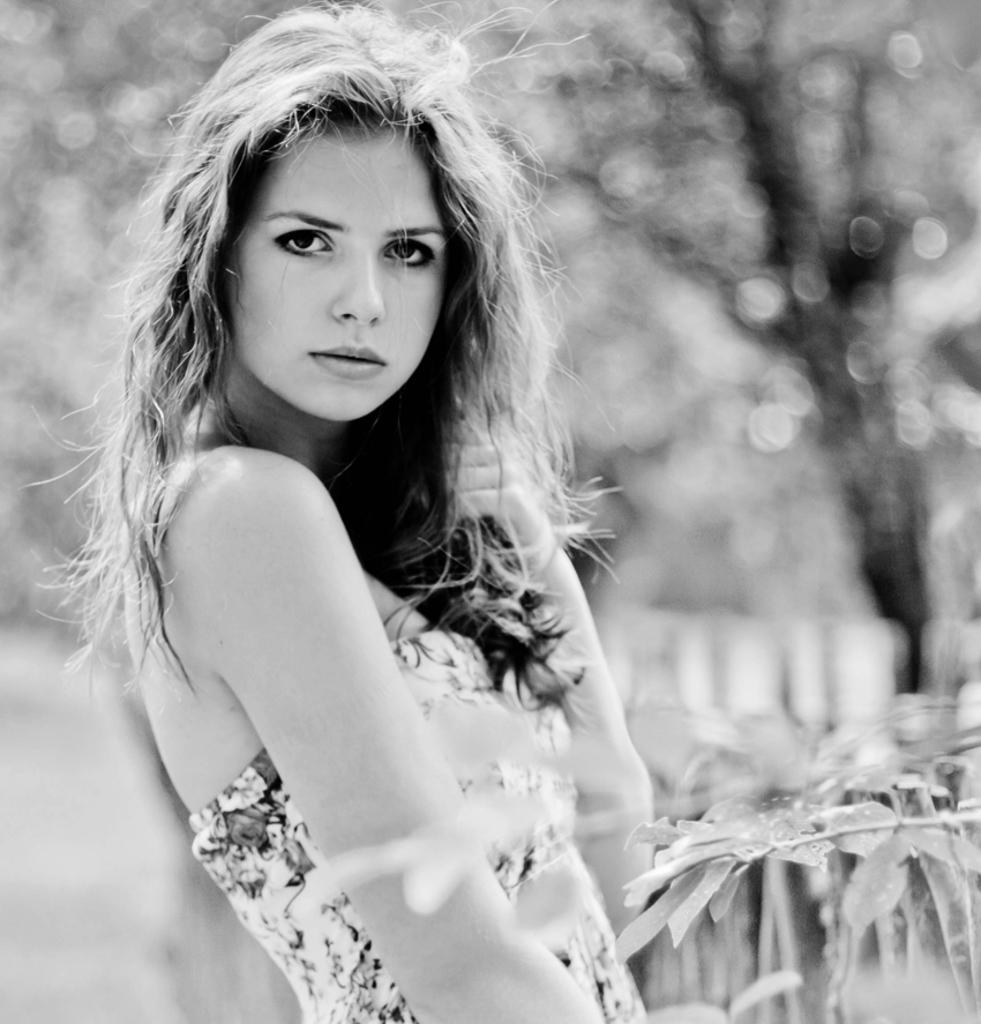What is the color scheme of the image? The image is black and white. What can be seen in the foreground of the image? There is a woman standing in the image. What type of vegetation is visible in the image? Leaves are visible in the image. How would you describe the background of the image? The background of the image is blurry. What type of pancake is being rolled down the way in the image? There is no pancake or rolling action present in the image. 